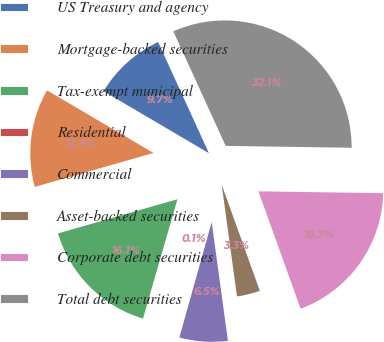Convert chart. <chart><loc_0><loc_0><loc_500><loc_500><pie_chart><fcel>US Treasury and agency<fcel>Mortgage-backed securities<fcel>Tax-exempt municipal<fcel>Residential<fcel>Commercial<fcel>Asset-backed securities<fcel>Corporate debt securities<fcel>Total debt securities<nl><fcel>9.71%<fcel>12.9%<fcel>16.09%<fcel>0.13%<fcel>6.51%<fcel>3.32%<fcel>19.28%<fcel>32.06%<nl></chart> 